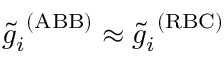Convert formula to latex. <formula><loc_0><loc_0><loc_500><loc_500>\tilde { g } _ { i } ^ { \ ( A B B ) } \approx \tilde { g } _ { i } ^ { \ ( R B C ) }</formula> 